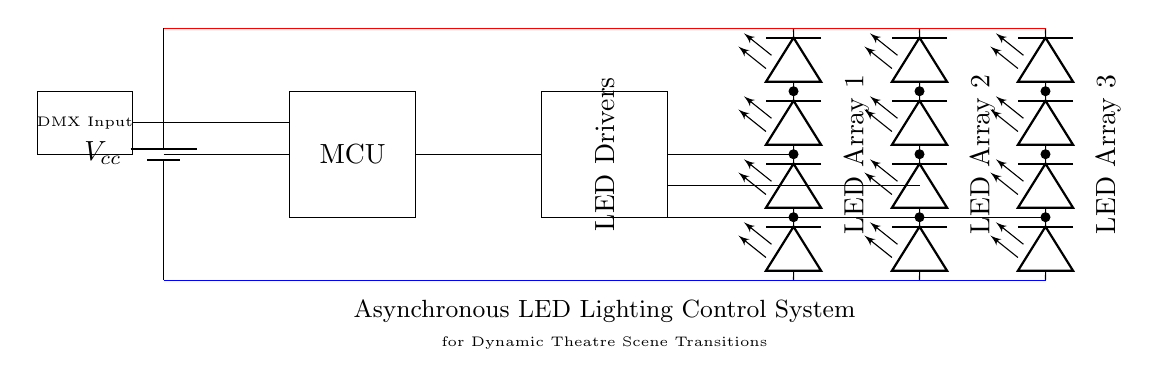What is the main power supply component used? The main power supply in the circuit is represented by the battery symbol, indicating it provides the necessary voltage to the system.
Answer: battery How many LED arrays are present in this circuit? The diagram shows three distinct LED arrays, each represented as a separate group of LED components.
Answer: three What controls the LED drivers in the system? The microcontroller, depicted as a rectangle marked 'MCU', is responsible for controlling the LED drivers by sending signals based on the DMX input.
Answer: microcontroller What type of input does the system accept? The circuit includes a DMX input component, indicating that it is designed to accept signals conforming to DMX lighting control protocols.
Answer: DMX What is the voltage level of the power supply? The main power supply voltage is not explicitly labeled, but it is connected from the battery component, typically representing a standard voltage such as twelve volts in many lighting applications.
Answer: Vcc How are the LED arrays connected to the drivers? The connection occurs through lines that lead from the LED drivers to each LED array, indicating that signals from the drivers control the operation of the LEDs based on the microcontroller input.
Answer: serially What is the function of the microcontroller in this circuit? The microcontroller interprets signals from the DMX input and directs the LED drivers to achieve dynamic scene transitions necessary for theater performances.
Answer: control 